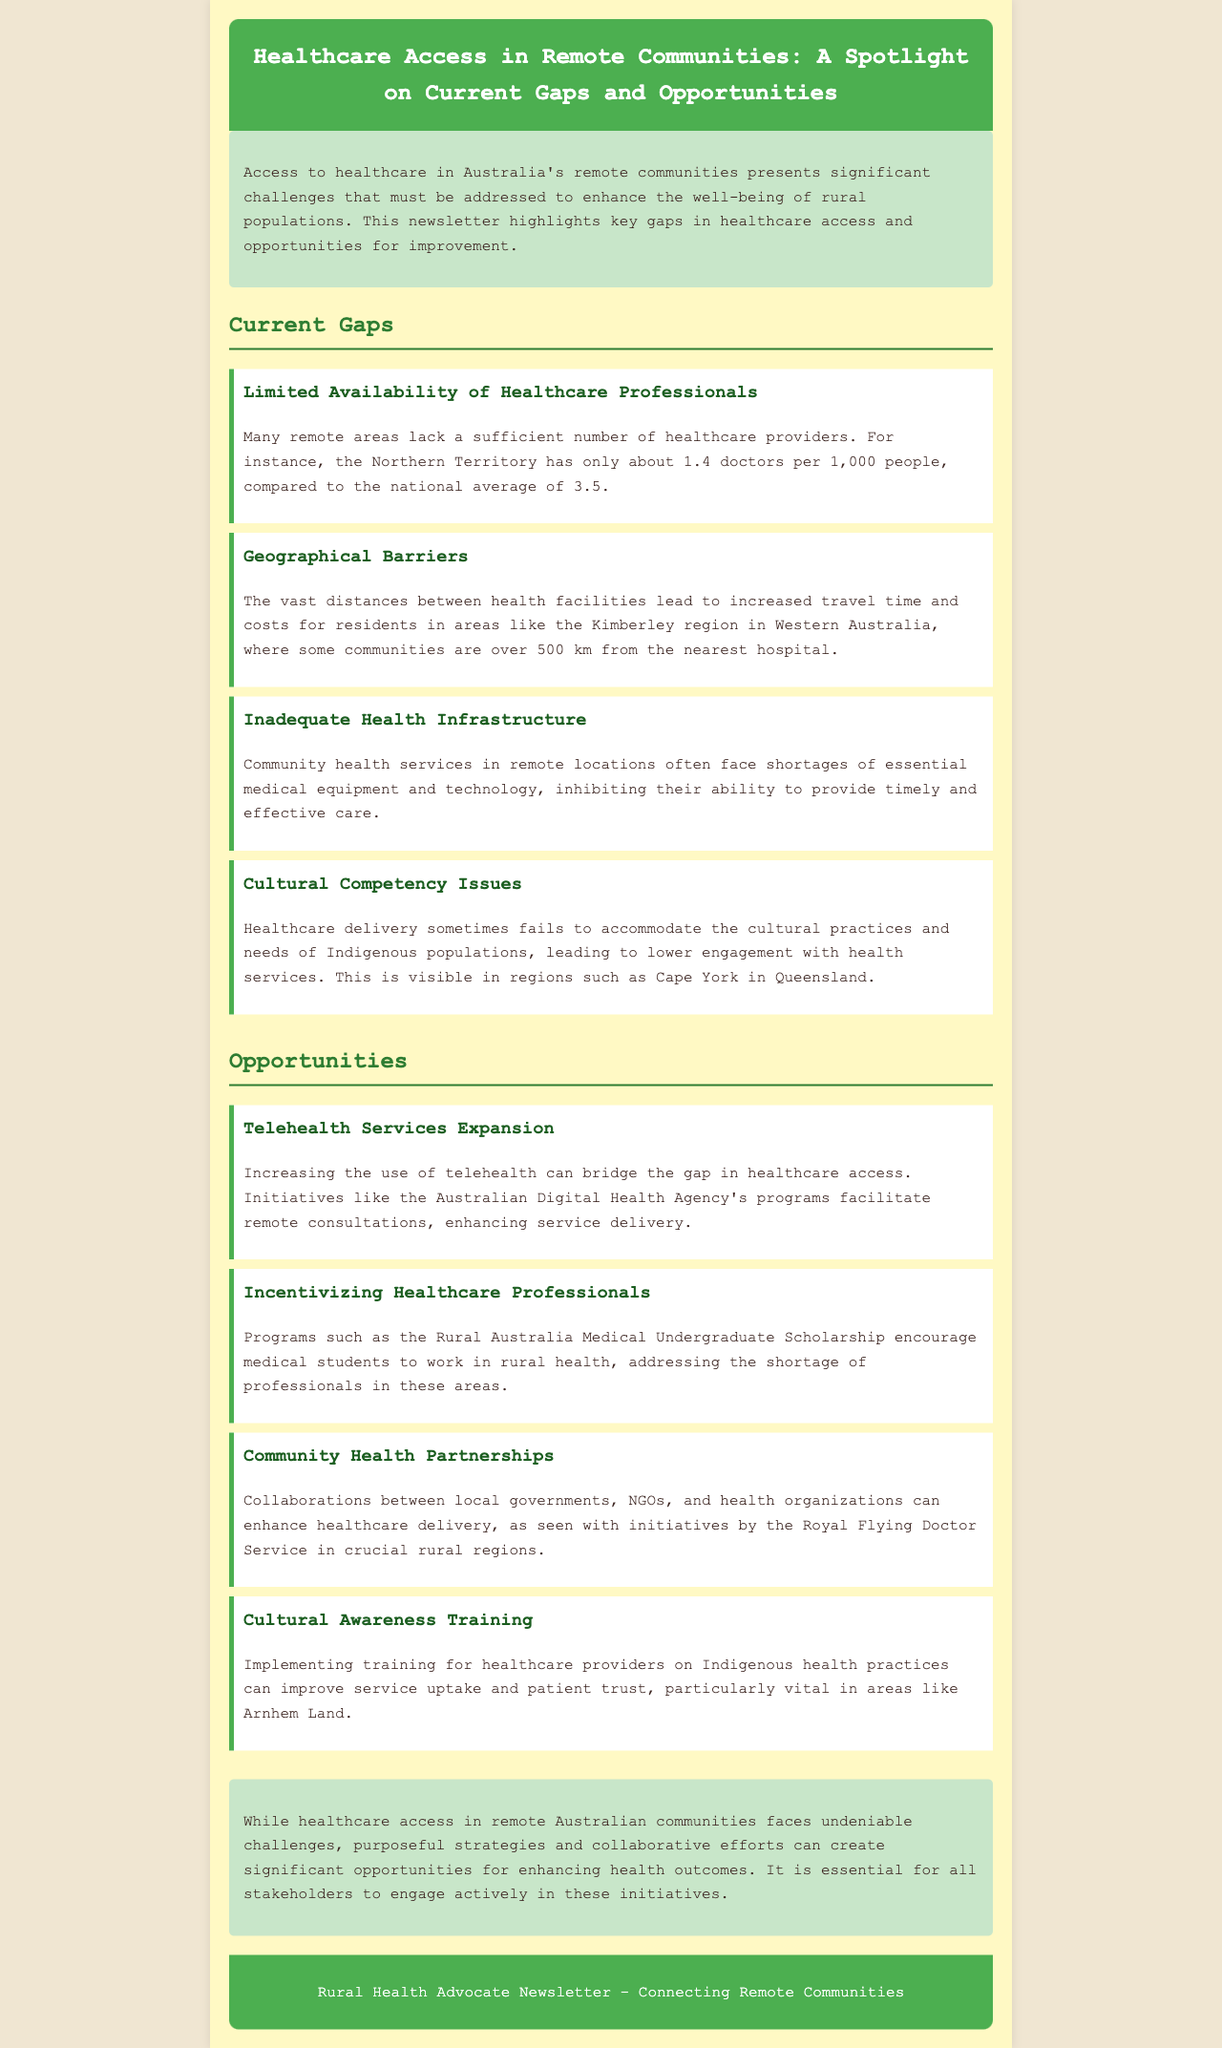What is the doctor-to-population ratio in the Northern Territory? The document states that the Northern Territory has only about 1.4 doctors per 1,000 people, compared to the national average of 3.5.
Answer: 1.4 doctors per 1,000 people What is a significant geographical barrier mentioned in the newsletter? The newsletter highlights that some communities in the Kimberley region in Western Australia are over 500 km from the nearest hospital.
Answer: Over 500 km from the nearest hospital What initiative encourages medical students to work in rural health? The Rural Australia Medical Undergraduate Scholarship is mentioned as a program that encourages medical students to work in rural health.
Answer: Rural Australia Medical Undergraduate Scholarship What cultural issue affects healthcare delivery for Indigenous populations? The document mentions that healthcare delivery sometimes fails to accommodate the cultural practices and needs of Indigenous populations.
Answer: Cultural practices and needs of Indigenous populations What opportunity involves enhancing remote consultations? Increasing the use of telehealth can bridge the gap in healthcare access and is highlighted as an opportunity in the document.
Answer: Telehealth services expansion What collaborative effort is mentioned to enhance healthcare delivery? The newsletter details that collaborations between local governments, NGOs, and health organizations can enhance healthcare delivery.
Answer: Community health partnerships What is a shortage faced by community health services in remote locations? The document states that community health services often face shortages of essential medical equipment and technology.
Answer: Shortages of essential medical equipment and technology Which area is highlighted for cultural awareness training for healthcare providers? The document emphasizes the importance of implementing training for healthcare providers on Indigenous health practices, particularly in Arnhem Land.
Answer: Arnhem Land 